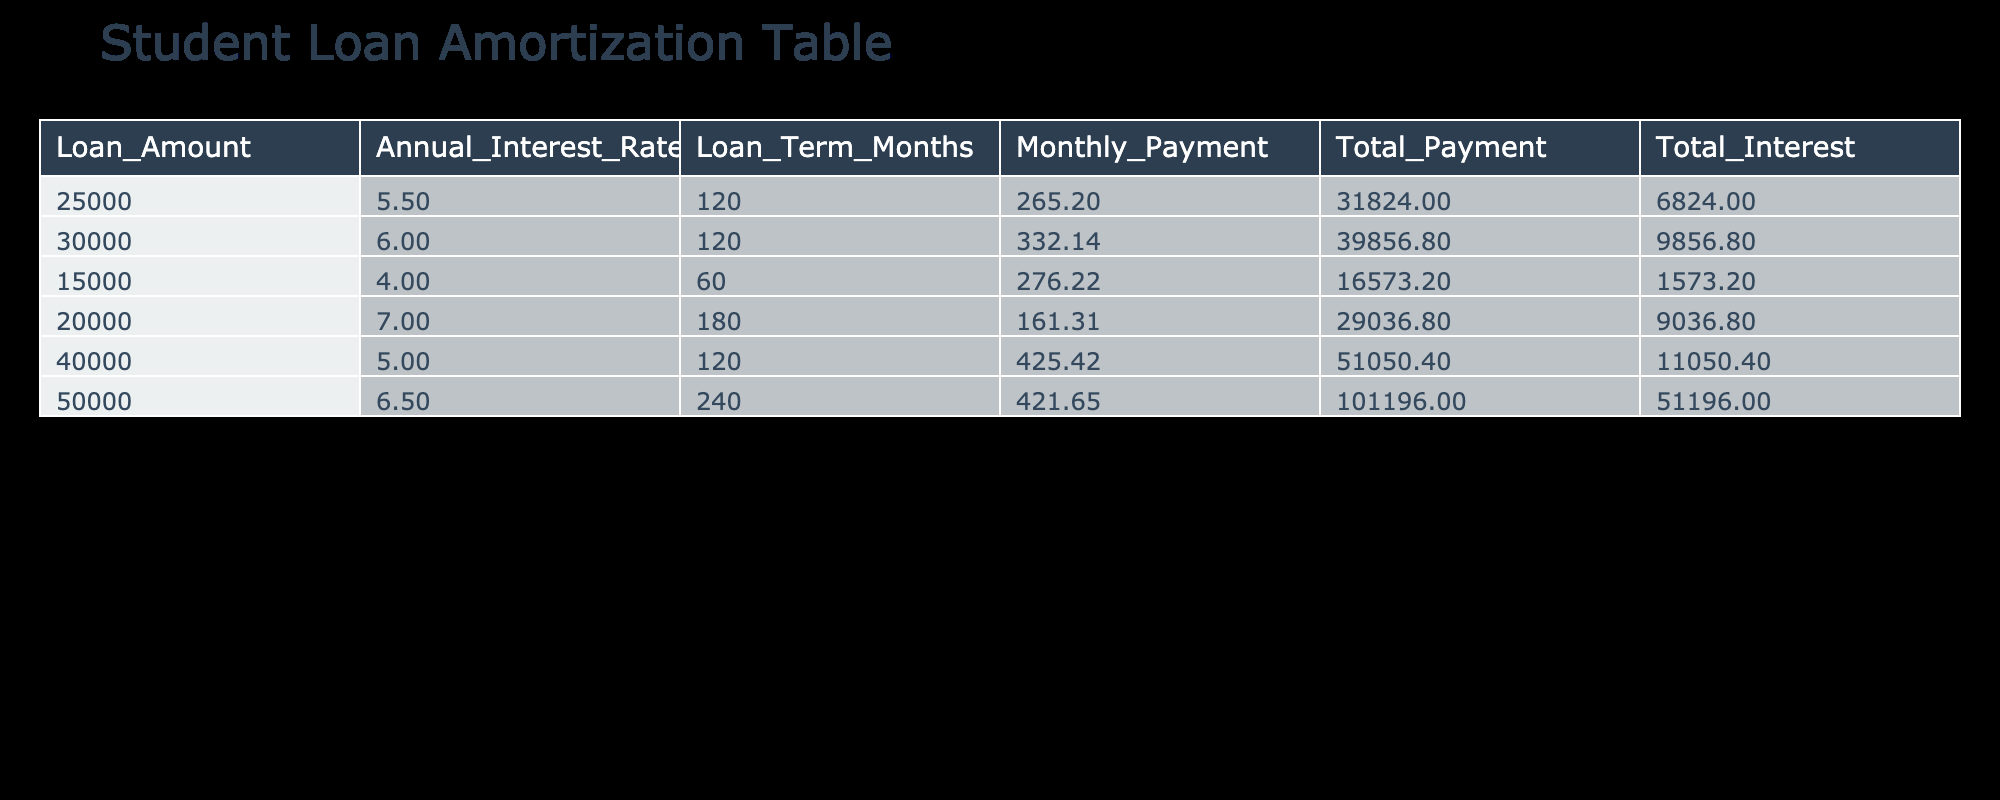What is the total interest paid for the 40000 loan? According to the table, the total interest paid for the loan amount of 40000 at a 5.0% interest rate over 120 months is clearly stated in the respective row. It can be found in the Total Interest column next to the 40000 loan.
Answer: 11050.40 What is the monthly payment for the 15000 loan? The monthly payment for the loan amount of 15000 can be found in the Monthly Payment column corresponding to that specific loan entry. It shows the value of 276.22.
Answer: 276.22 Is the total payment for the 25000 loan higher than the total payment for the 20000 loan? The total payment for the 25000 loan is 31824.00, while the total payment for the 20000 loan is 29036.80. Since 31824.00 is greater than 29036.80, the answer is yes.
Answer: Yes What is the average total payment across all loans? To find the average total payment, we first sum all the total payments: 31824.00 + 39856.80 + 16573.20 + 29036.80 + 51050.40 + 101196.00 = 202636.00. Then, we divide this sum by the total number of loans, which is 6. Thus, the average total payment is 202636.00 / 6 = 33772.67.
Answer: 33772.67 Which loan has the highest total interest paid? By looking at the Total Interest column, we find the highest value. The total interest paid for the 50000 loan is 51196.00, which is greater than all others listed.
Answer: 51196.00 How much does the total payment of the 30000 loan exceed the monthly payment of the 25000 loan? The total payment for the 30000 loan is 39856.80, and the monthly payment for the 25000 loan is 265.20 (multiplied by the number of months, which is 120, gives 31824.00). To find the difference, we compute 39856.80 - 31824.00 = 8026.80.
Answer: 8026.80 Is the monthly payment for the 50000 loan less than 500? The monthly payment for the 50000 loan is 421.65. Since this value is less than 500, the answer is yes.
Answer: Yes What is the difference in total interest between the 40000 loan and the 15000 loan? The total interest for the 40000 loan is 11050.40, and for the 15000 loan, it is 1573.20. To find the difference, we subtract the smaller interest from the larger one: 11050.40 - 1573.20 = 9487.20.
Answer: 9487.20 